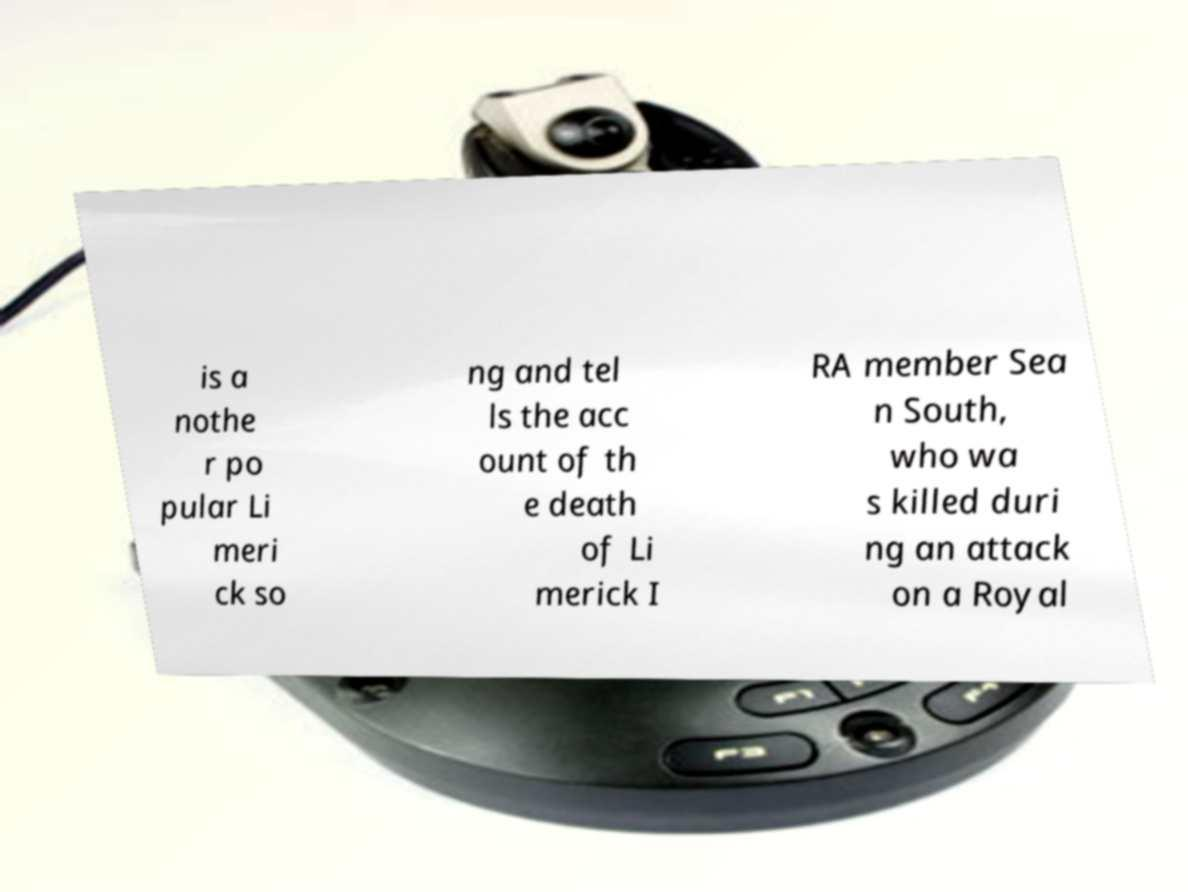What messages or text are displayed in this image? I need them in a readable, typed format. is a nothe r po pular Li meri ck so ng and tel ls the acc ount of th e death of Li merick I RA member Sea n South, who wa s killed duri ng an attack on a Royal 